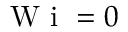<formula> <loc_0><loc_0><loc_500><loc_500>W i = 0</formula> 